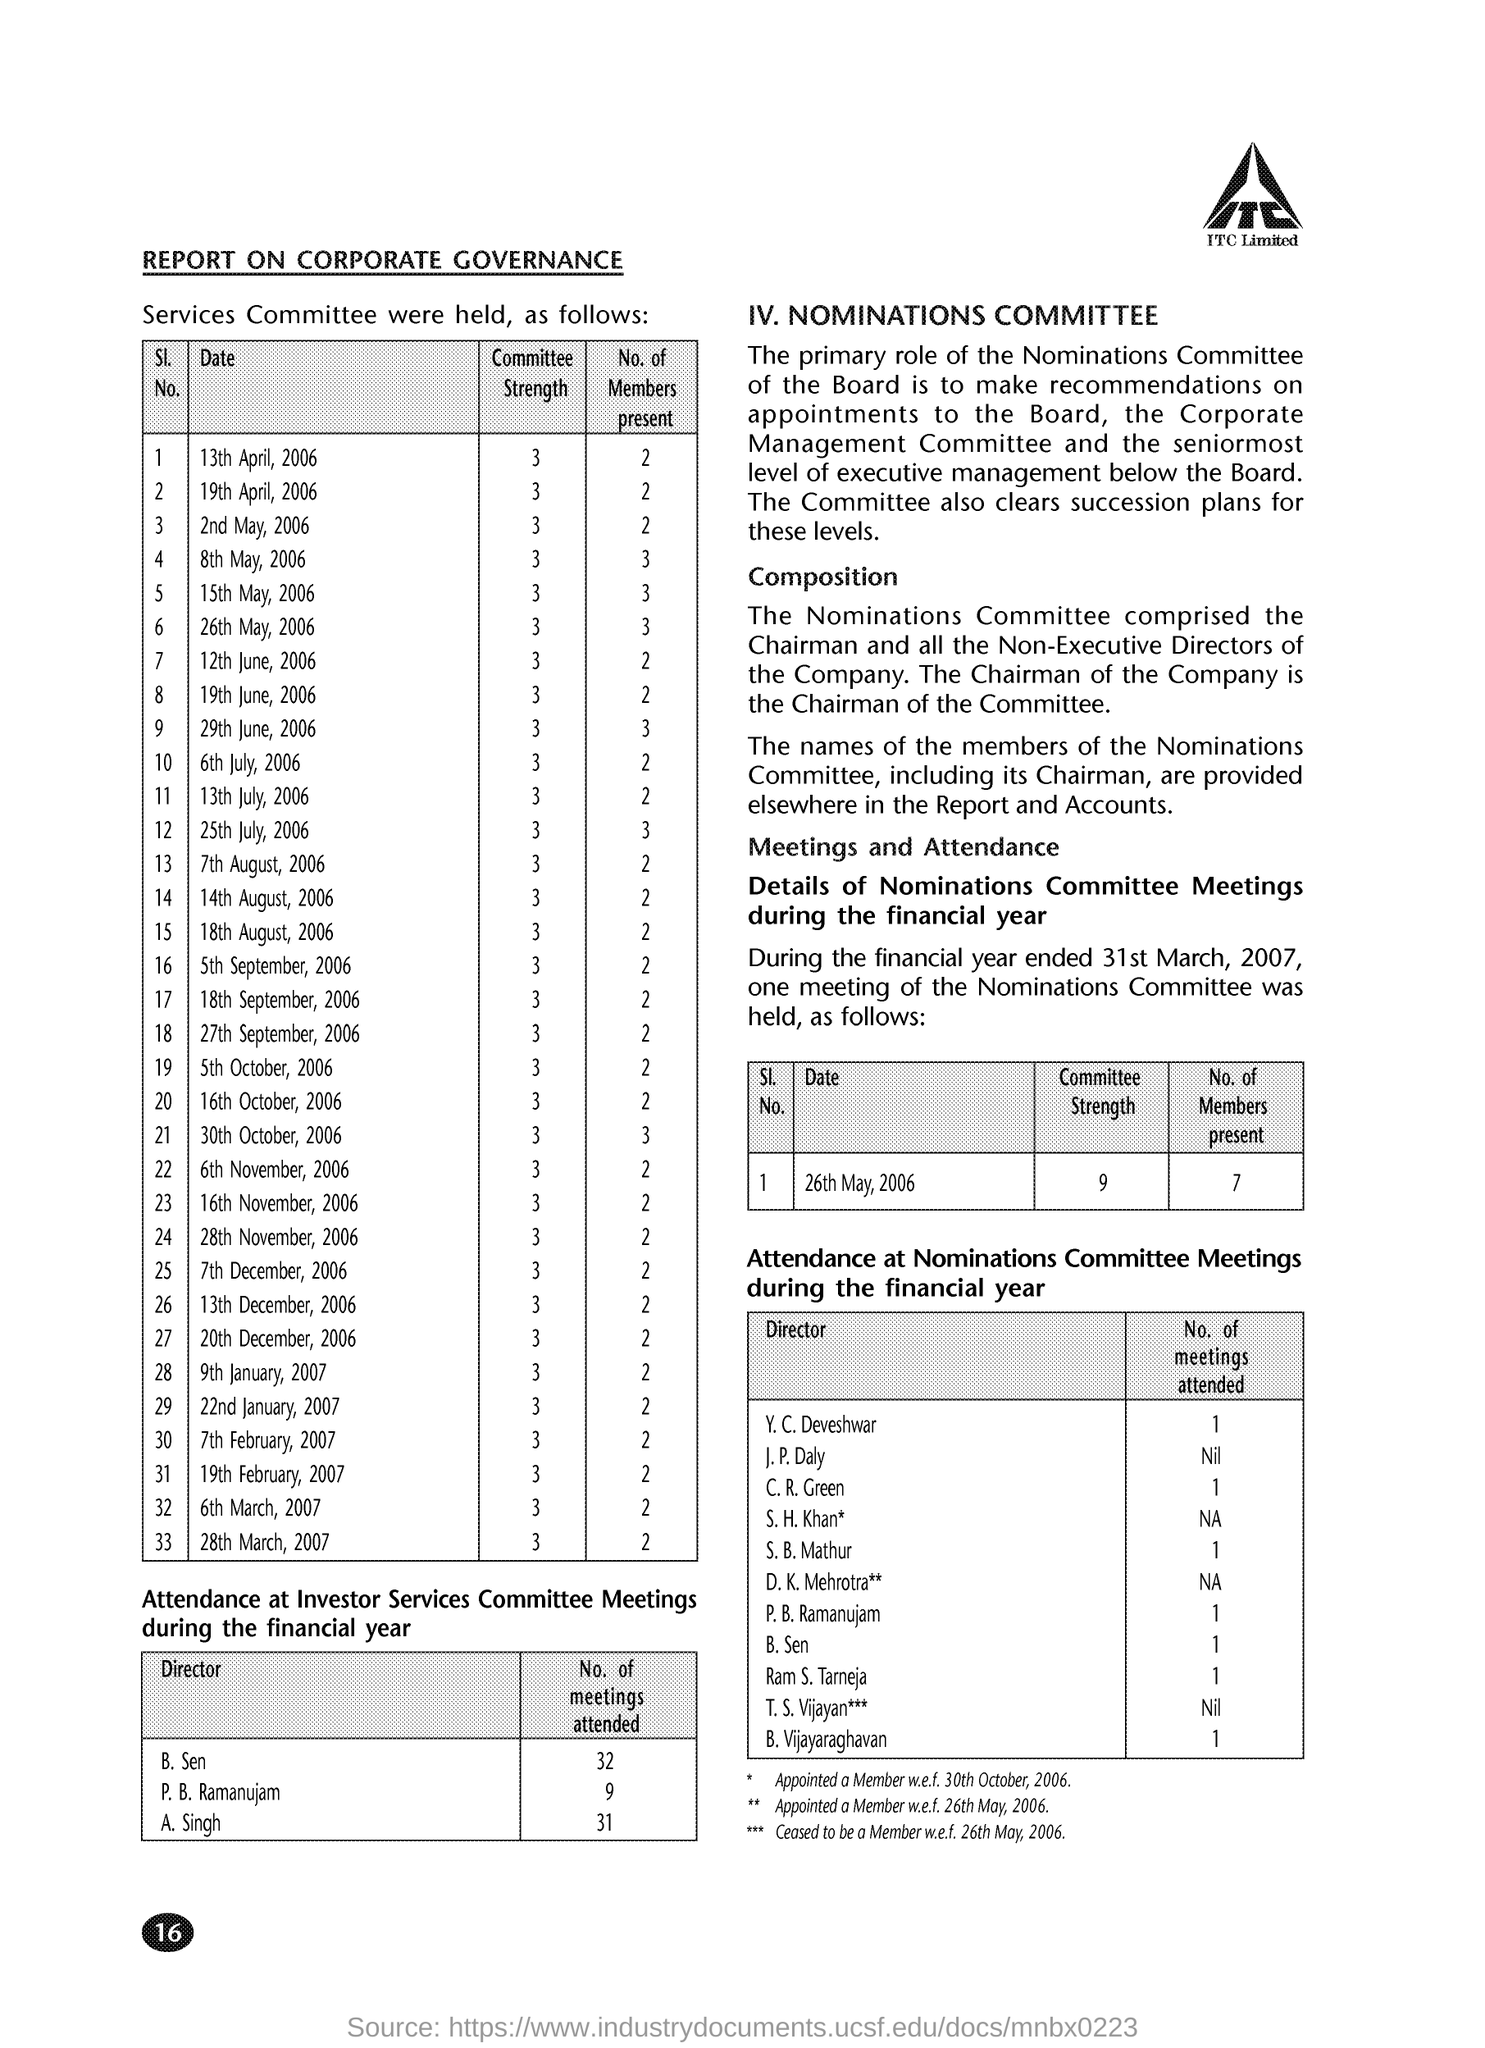Mention a couple of crucial points in this snapshot. On April 19th, 2006, the committee strength was 3... On May 15, 2006, the committee strength was 3... On July 13, 2006, the number of members present was two. There were 2 members present at the meeting held on April 13, 2006. On July 6th, 2006, the committee strength was 3. 